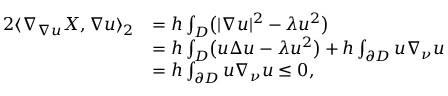Convert formula to latex. <formula><loc_0><loc_0><loc_500><loc_500>\begin{array} { r l } { 2 \langle \nabla _ { \nabla u } X , \nabla u \rangle _ { 2 } } & { = h \int _ { D } \left ( | \nabla u | ^ { 2 } - \lambda u ^ { 2 } \right ) } \\ & { = h \int _ { D } \left ( u \Delta u - \lambda u ^ { 2 } \right ) + h \int _ { \partial D } u \nabla _ { \nu } u } \\ & { = h \int _ { \partial D } u \nabla _ { \nu } u \leq 0 , } \end{array}</formula> 